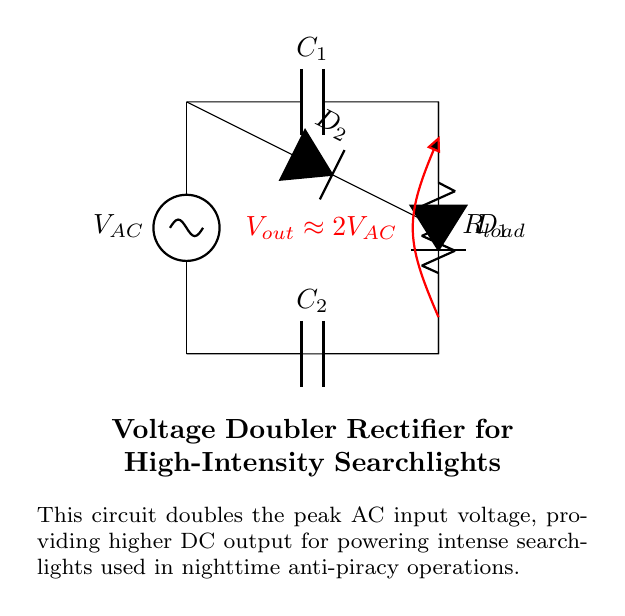What is the purpose of this circuit? The purpose is to double the peak AC input voltage to provide higher DC output. This is useful for powering high-intensity searchlights required in nighttime anti-piracy operations.
Answer: To power searchlights What type of capacitors are used in this circuit? The circuit contains two capacitors, labeled C1 and C2. Both are used for smoothing the rectified voltage and storing charge.
Answer: Two capacitors What is the output voltage approximately? The output voltage is approximately double the input AC voltage due to the voltage doubling configuration of the circuit. This is indicated as Vout approximately equal to 2Vac.
Answer: 2Vac How many diodes are present in this circuit? There are two diodes labeled D1 and D2, which are used for rectification in the circuit to allow current to flow in one direction only, converting AC to DC.
Answer: Two diodes What is the load component in this circuit? The load component, labeled Rload, represents the resistive load (such as the searchlight) that consumes the output power from the rectifier circuit.
Answer: Rload Why is this circuit suitable for nighttime anti-piracy operations? This circuit is suitable because it provides a higher DC voltage output necessary for powering high-intensity searchlights, which are critical for visibility during nighttime operations.
Answer: Higher DC output 